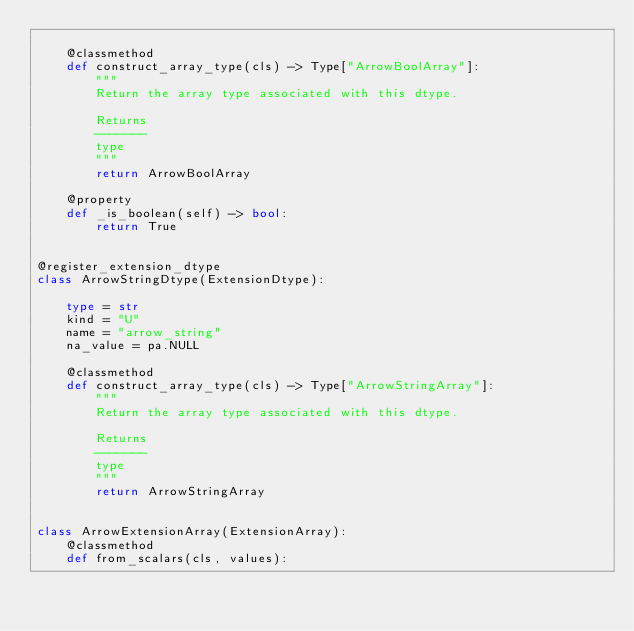<code> <loc_0><loc_0><loc_500><loc_500><_Python_>
    @classmethod
    def construct_array_type(cls) -> Type["ArrowBoolArray"]:
        """
        Return the array type associated with this dtype.

        Returns
        -------
        type
        """
        return ArrowBoolArray

    @property
    def _is_boolean(self) -> bool:
        return True


@register_extension_dtype
class ArrowStringDtype(ExtensionDtype):

    type = str
    kind = "U"
    name = "arrow_string"
    na_value = pa.NULL

    @classmethod
    def construct_array_type(cls) -> Type["ArrowStringArray"]:
        """
        Return the array type associated with this dtype.

        Returns
        -------
        type
        """
        return ArrowStringArray


class ArrowExtensionArray(ExtensionArray):
    @classmethod
    def from_scalars(cls, values):</code> 